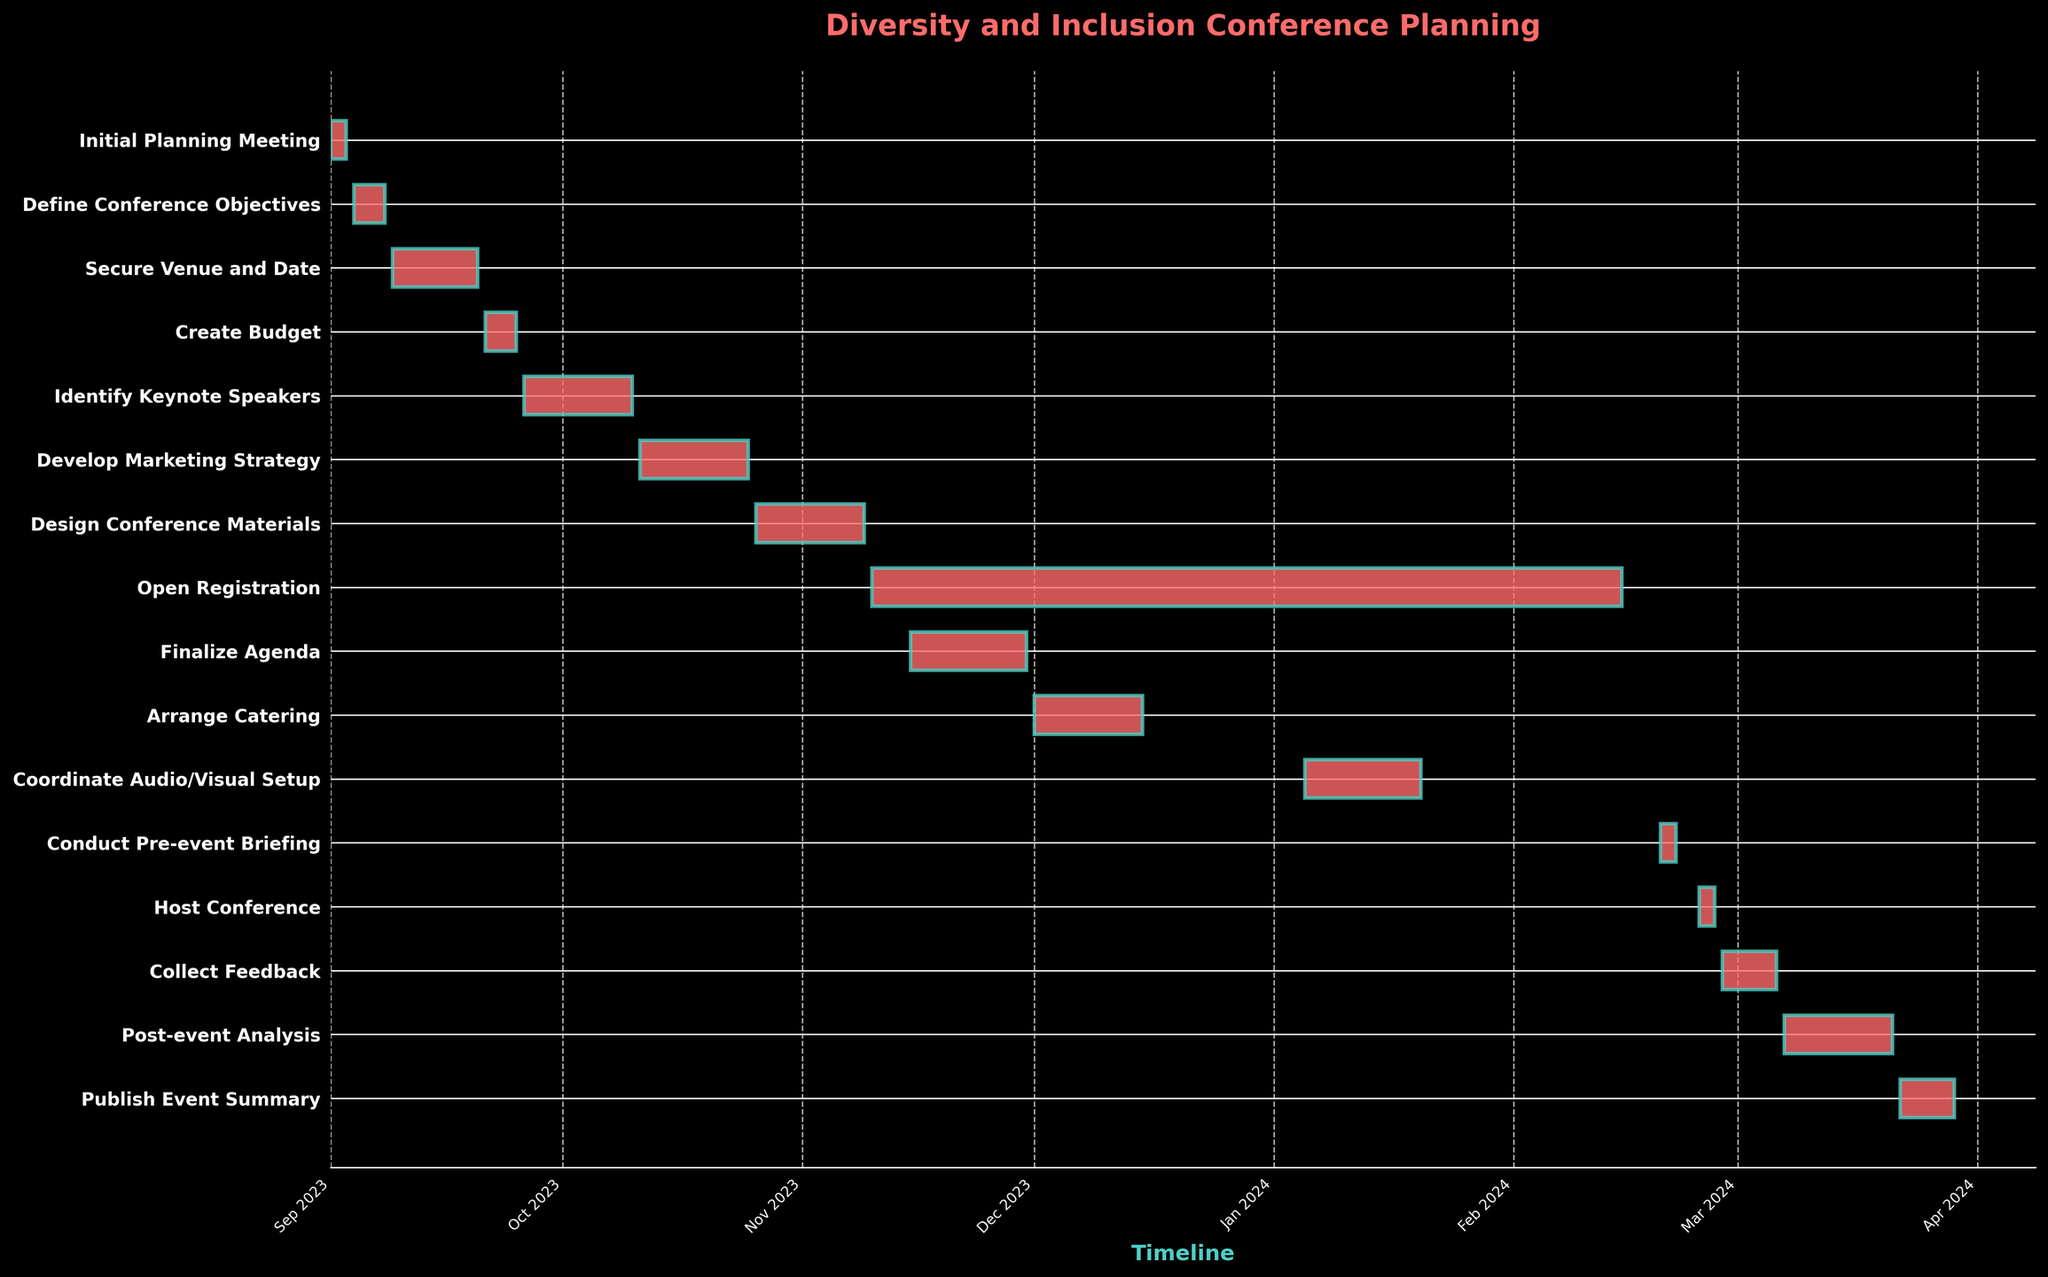What is the title of the figure? The title is typically found at the top of the figure and describes what the plot is about. In this case, it indicates the main theme of the Gantt Chart.
Answer: Diversity and Inclusion Conference Planning How many tasks are there in total for organizing the conference? Each bar in the Gantt Chart represents a task. By counting all the bars, we can determine the total number of tasks.
Answer: 15 Which task has the longest duration? The task with the longest bar on the Gantt Chart indicates the longest duration.
Answer: Open Registration Which task will begin immediately after ‘Create Budget’? By looking at the end date of the 'Create Budget' task and observing which task starts directly after that, we find the immediate subsequent task.
Answer: Identify Keynote Speakers During which months does the 'Host Conference' task occur? By locating the ‘Host Conference’ task on the timeline and reading the corresponding timeframe, we can determine the involved months.
Answer: February 2024 What is the duration of the 'Collect Feedback' task in days? The duration can be calculated by counting the number of days from the start to the end date of the ‘Collect Feedback’ task.
Answer: 7 days Which task starts the earliest, and which task starts the latest? By checking the start dates of all tasks on the Gantt Chart, we can identify the tasks that start the earliest and the latest.
Answer: Initial Planning Meeting starts earliest and Conduct Pre-event Briefing starts latest Between which two tasks does the 'Finalize Agenda' fit in terms of start and end dates? By locating the 'Finalize Agenda' task and examining the start and end dates of tasks before and after it, we can determine its position.
Answer: After Open Registration and before Arrange Catering How many tasks are planned to take place in December 2023? By checking the timeline for the month of December 2023 on the Gantt Chart, we can count the number of tasks falling within that month.
Answer: 1 task What is the cumulative duration of 'Identify Keynote Speakers' and 'Develop Marketing Strategy'? The duration of 'Identify Keynote Speakers' and 'Develop Marketing Strategy' can be summed by adding the number of days each task spans.
Answer: 24 days 